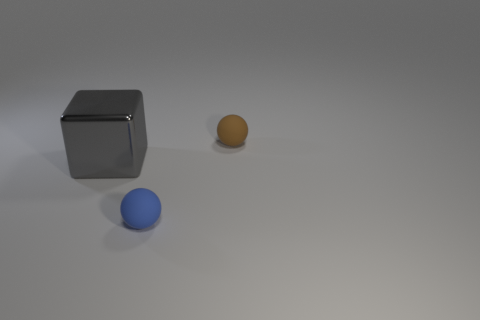Is there anything else that has the same size as the block?
Make the answer very short. No. Are there any spheres made of the same material as the blue thing?
Offer a terse response. Yes. Is the size of the gray cube the same as the blue ball?
Keep it short and to the point. No. How many balls are either purple matte objects or small blue things?
Offer a very short reply. 1. What number of blue matte objects are the same shape as the brown object?
Provide a short and direct response. 1. Are there more balls on the left side of the tiny brown rubber sphere than tiny blue balls that are on the left side of the large metallic block?
Make the answer very short. Yes. What is the size of the shiny cube?
Your answer should be compact. Large. There is a blue thing that is the same size as the brown object; what is it made of?
Provide a succinct answer. Rubber. The matte object in front of the tiny brown matte object is what color?
Provide a succinct answer. Blue. What number of small brown rubber things are there?
Ensure brevity in your answer.  1. 